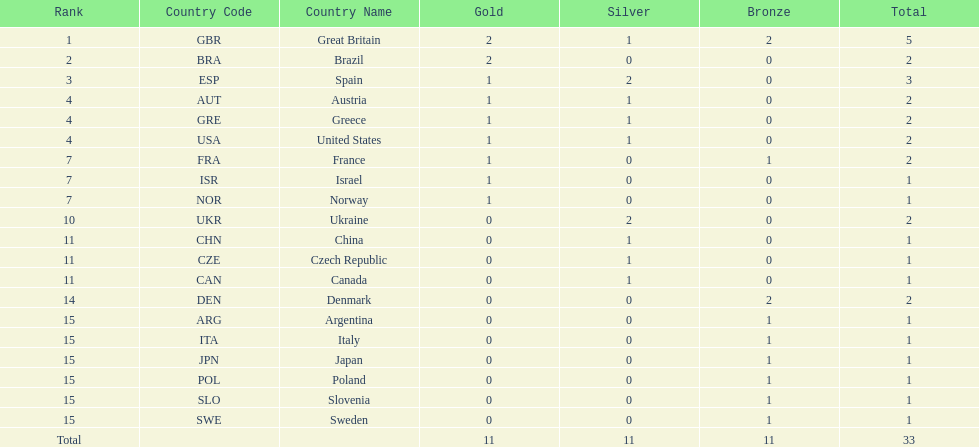What was the total number of medals won by united states? 2. 